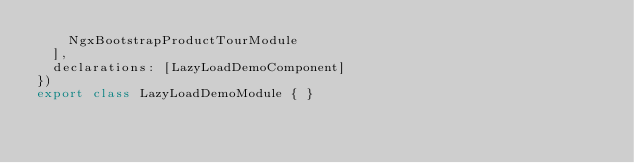<code> <loc_0><loc_0><loc_500><loc_500><_TypeScript_>    NgxBootstrapProductTourModule
  ],
  declarations: [LazyLoadDemoComponent]
})
export class LazyLoadDemoModule { }
</code> 